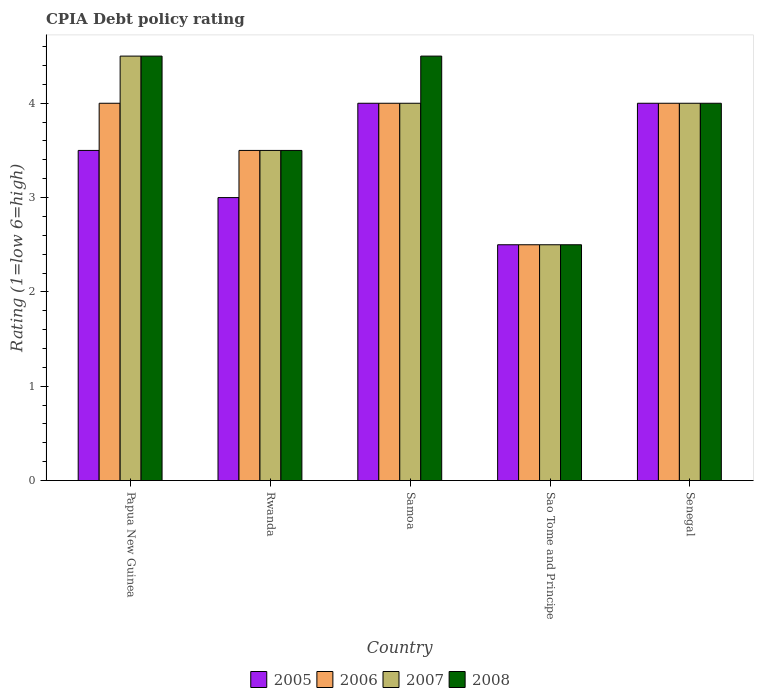How many different coloured bars are there?
Give a very brief answer. 4. How many groups of bars are there?
Provide a short and direct response. 5. Are the number of bars on each tick of the X-axis equal?
Provide a short and direct response. Yes. How many bars are there on the 4th tick from the right?
Give a very brief answer. 4. What is the label of the 3rd group of bars from the left?
Your response must be concise. Samoa. In how many cases, is the number of bars for a given country not equal to the number of legend labels?
Your answer should be very brief. 0. In which country was the CPIA rating in 2007 maximum?
Provide a succinct answer. Papua New Guinea. In which country was the CPIA rating in 2007 minimum?
Ensure brevity in your answer.  Sao Tome and Principe. What is the total CPIA rating in 2008 in the graph?
Give a very brief answer. 19. What is the difference between the CPIA rating in 2007 in Senegal and the CPIA rating in 2005 in Papua New Guinea?
Offer a terse response. 0.5. What is the difference between the highest and the lowest CPIA rating in 2008?
Give a very brief answer. 2. In how many countries, is the CPIA rating in 2005 greater than the average CPIA rating in 2005 taken over all countries?
Make the answer very short. 3. Is it the case that in every country, the sum of the CPIA rating in 2008 and CPIA rating in 2005 is greater than the sum of CPIA rating in 2007 and CPIA rating in 2006?
Make the answer very short. No. What does the 1st bar from the left in Samoa represents?
Offer a very short reply. 2005. What does the 2nd bar from the right in Senegal represents?
Your answer should be very brief. 2007. Is it the case that in every country, the sum of the CPIA rating in 2007 and CPIA rating in 2005 is greater than the CPIA rating in 2006?
Your answer should be compact. Yes. How many bars are there?
Ensure brevity in your answer.  20. Are all the bars in the graph horizontal?
Keep it short and to the point. No. Are the values on the major ticks of Y-axis written in scientific E-notation?
Your response must be concise. No. How many legend labels are there?
Make the answer very short. 4. What is the title of the graph?
Your answer should be compact. CPIA Debt policy rating. What is the Rating (1=low 6=high) in 2005 in Papua New Guinea?
Give a very brief answer. 3.5. What is the Rating (1=low 6=high) of 2007 in Papua New Guinea?
Your response must be concise. 4.5. What is the Rating (1=low 6=high) in 2005 in Rwanda?
Provide a succinct answer. 3. What is the Rating (1=low 6=high) in 2007 in Rwanda?
Provide a short and direct response. 3.5. What is the Rating (1=low 6=high) in 2008 in Rwanda?
Provide a succinct answer. 3.5. What is the Rating (1=low 6=high) of 2005 in Samoa?
Offer a very short reply. 4. What is the Rating (1=low 6=high) of 2007 in Samoa?
Offer a very short reply. 4. What is the Rating (1=low 6=high) in 2006 in Senegal?
Give a very brief answer. 4. What is the Rating (1=low 6=high) of 2007 in Senegal?
Make the answer very short. 4. What is the Rating (1=low 6=high) in 2008 in Senegal?
Provide a succinct answer. 4. Across all countries, what is the maximum Rating (1=low 6=high) of 2005?
Provide a short and direct response. 4. Across all countries, what is the maximum Rating (1=low 6=high) of 2006?
Provide a short and direct response. 4. Across all countries, what is the maximum Rating (1=low 6=high) in 2008?
Offer a very short reply. 4.5. Across all countries, what is the minimum Rating (1=low 6=high) of 2007?
Keep it short and to the point. 2.5. What is the difference between the Rating (1=low 6=high) in 2005 in Papua New Guinea and that in Rwanda?
Provide a succinct answer. 0.5. What is the difference between the Rating (1=low 6=high) of 2007 in Papua New Guinea and that in Rwanda?
Your response must be concise. 1. What is the difference between the Rating (1=low 6=high) in 2008 in Papua New Guinea and that in Samoa?
Your response must be concise. 0. What is the difference between the Rating (1=low 6=high) in 2005 in Papua New Guinea and that in Sao Tome and Principe?
Provide a succinct answer. 1. What is the difference between the Rating (1=low 6=high) of 2006 in Papua New Guinea and that in Sao Tome and Principe?
Ensure brevity in your answer.  1.5. What is the difference between the Rating (1=low 6=high) in 2005 in Papua New Guinea and that in Senegal?
Provide a short and direct response. -0.5. What is the difference between the Rating (1=low 6=high) in 2006 in Papua New Guinea and that in Senegal?
Offer a very short reply. 0. What is the difference between the Rating (1=low 6=high) in 2007 in Papua New Guinea and that in Senegal?
Make the answer very short. 0.5. What is the difference between the Rating (1=low 6=high) in 2007 in Rwanda and that in Samoa?
Provide a succinct answer. -0.5. What is the difference between the Rating (1=low 6=high) of 2007 in Rwanda and that in Sao Tome and Principe?
Ensure brevity in your answer.  1. What is the difference between the Rating (1=low 6=high) of 2005 in Rwanda and that in Senegal?
Keep it short and to the point. -1. What is the difference between the Rating (1=low 6=high) in 2007 in Rwanda and that in Senegal?
Keep it short and to the point. -0.5. What is the difference between the Rating (1=low 6=high) in 2005 in Samoa and that in Sao Tome and Principe?
Provide a succinct answer. 1.5. What is the difference between the Rating (1=low 6=high) in 2006 in Samoa and that in Sao Tome and Principe?
Ensure brevity in your answer.  1.5. What is the difference between the Rating (1=low 6=high) of 2007 in Samoa and that in Sao Tome and Principe?
Offer a very short reply. 1.5. What is the difference between the Rating (1=low 6=high) of 2008 in Samoa and that in Sao Tome and Principe?
Keep it short and to the point. 2. What is the difference between the Rating (1=low 6=high) of 2005 in Samoa and that in Senegal?
Make the answer very short. 0. What is the difference between the Rating (1=low 6=high) in 2007 in Samoa and that in Senegal?
Give a very brief answer. 0. What is the difference between the Rating (1=low 6=high) in 2005 in Sao Tome and Principe and that in Senegal?
Ensure brevity in your answer.  -1.5. What is the difference between the Rating (1=low 6=high) in 2007 in Sao Tome and Principe and that in Senegal?
Make the answer very short. -1.5. What is the difference between the Rating (1=low 6=high) in 2005 in Papua New Guinea and the Rating (1=low 6=high) in 2008 in Rwanda?
Provide a succinct answer. 0. What is the difference between the Rating (1=low 6=high) of 2007 in Papua New Guinea and the Rating (1=low 6=high) of 2008 in Rwanda?
Provide a succinct answer. 1. What is the difference between the Rating (1=low 6=high) of 2005 in Papua New Guinea and the Rating (1=low 6=high) of 2008 in Samoa?
Ensure brevity in your answer.  -1. What is the difference between the Rating (1=low 6=high) in 2006 in Papua New Guinea and the Rating (1=low 6=high) in 2008 in Samoa?
Keep it short and to the point. -0.5. What is the difference between the Rating (1=low 6=high) of 2005 in Papua New Guinea and the Rating (1=low 6=high) of 2008 in Sao Tome and Principe?
Your answer should be very brief. 1. What is the difference between the Rating (1=low 6=high) of 2007 in Papua New Guinea and the Rating (1=low 6=high) of 2008 in Sao Tome and Principe?
Make the answer very short. 2. What is the difference between the Rating (1=low 6=high) of 2006 in Papua New Guinea and the Rating (1=low 6=high) of 2007 in Senegal?
Give a very brief answer. 0. What is the difference between the Rating (1=low 6=high) of 2006 in Papua New Guinea and the Rating (1=low 6=high) of 2008 in Senegal?
Give a very brief answer. 0. What is the difference between the Rating (1=low 6=high) in 2007 in Papua New Guinea and the Rating (1=low 6=high) in 2008 in Senegal?
Your response must be concise. 0.5. What is the difference between the Rating (1=low 6=high) in 2005 in Rwanda and the Rating (1=low 6=high) in 2006 in Samoa?
Provide a succinct answer. -1. What is the difference between the Rating (1=low 6=high) in 2005 in Rwanda and the Rating (1=low 6=high) in 2008 in Samoa?
Ensure brevity in your answer.  -1.5. What is the difference between the Rating (1=low 6=high) of 2007 in Rwanda and the Rating (1=low 6=high) of 2008 in Samoa?
Your answer should be compact. -1. What is the difference between the Rating (1=low 6=high) in 2005 in Rwanda and the Rating (1=low 6=high) in 2006 in Sao Tome and Principe?
Provide a succinct answer. 0.5. What is the difference between the Rating (1=low 6=high) of 2005 in Rwanda and the Rating (1=low 6=high) of 2007 in Sao Tome and Principe?
Your response must be concise. 0.5. What is the difference between the Rating (1=low 6=high) in 2006 in Rwanda and the Rating (1=low 6=high) in 2008 in Sao Tome and Principe?
Make the answer very short. 1. What is the difference between the Rating (1=low 6=high) in 2005 in Rwanda and the Rating (1=low 6=high) in 2007 in Senegal?
Your answer should be very brief. -1. What is the difference between the Rating (1=low 6=high) in 2005 in Rwanda and the Rating (1=low 6=high) in 2008 in Senegal?
Your answer should be very brief. -1. What is the difference between the Rating (1=low 6=high) of 2006 in Rwanda and the Rating (1=low 6=high) of 2007 in Senegal?
Provide a succinct answer. -0.5. What is the difference between the Rating (1=low 6=high) of 2007 in Rwanda and the Rating (1=low 6=high) of 2008 in Senegal?
Your answer should be compact. -0.5. What is the difference between the Rating (1=low 6=high) in 2005 in Samoa and the Rating (1=low 6=high) in 2007 in Sao Tome and Principe?
Make the answer very short. 1.5. What is the difference between the Rating (1=low 6=high) of 2007 in Samoa and the Rating (1=low 6=high) of 2008 in Sao Tome and Principe?
Ensure brevity in your answer.  1.5. What is the difference between the Rating (1=low 6=high) of 2005 in Samoa and the Rating (1=low 6=high) of 2006 in Senegal?
Your response must be concise. 0. What is the difference between the Rating (1=low 6=high) in 2005 in Samoa and the Rating (1=low 6=high) in 2007 in Senegal?
Ensure brevity in your answer.  0. What is the difference between the Rating (1=low 6=high) in 2006 in Samoa and the Rating (1=low 6=high) in 2008 in Senegal?
Provide a short and direct response. 0. What is the difference between the Rating (1=low 6=high) in 2007 in Samoa and the Rating (1=low 6=high) in 2008 in Senegal?
Ensure brevity in your answer.  0. What is the difference between the Rating (1=low 6=high) of 2005 in Sao Tome and Principe and the Rating (1=low 6=high) of 2008 in Senegal?
Your answer should be compact. -1.5. What is the difference between the Rating (1=low 6=high) of 2006 in Sao Tome and Principe and the Rating (1=low 6=high) of 2008 in Senegal?
Your answer should be very brief. -1.5. What is the difference between the Rating (1=low 6=high) in 2007 in Sao Tome and Principe and the Rating (1=low 6=high) in 2008 in Senegal?
Make the answer very short. -1.5. What is the average Rating (1=low 6=high) in 2005 per country?
Offer a terse response. 3.4. What is the average Rating (1=low 6=high) of 2007 per country?
Your response must be concise. 3.7. What is the average Rating (1=low 6=high) in 2008 per country?
Give a very brief answer. 3.8. What is the difference between the Rating (1=low 6=high) in 2005 and Rating (1=low 6=high) in 2006 in Papua New Guinea?
Provide a short and direct response. -0.5. What is the difference between the Rating (1=low 6=high) in 2005 and Rating (1=low 6=high) in 2007 in Papua New Guinea?
Offer a terse response. -1. What is the difference between the Rating (1=low 6=high) in 2005 and Rating (1=low 6=high) in 2008 in Papua New Guinea?
Ensure brevity in your answer.  -1. What is the difference between the Rating (1=low 6=high) in 2006 and Rating (1=low 6=high) in 2007 in Papua New Guinea?
Provide a short and direct response. -0.5. What is the difference between the Rating (1=low 6=high) in 2006 and Rating (1=low 6=high) in 2008 in Papua New Guinea?
Offer a very short reply. -0.5. What is the difference between the Rating (1=low 6=high) of 2007 and Rating (1=low 6=high) of 2008 in Papua New Guinea?
Make the answer very short. 0. What is the difference between the Rating (1=low 6=high) of 2005 and Rating (1=low 6=high) of 2006 in Rwanda?
Make the answer very short. -0.5. What is the difference between the Rating (1=low 6=high) of 2005 and Rating (1=low 6=high) of 2007 in Rwanda?
Give a very brief answer. -0.5. What is the difference between the Rating (1=low 6=high) in 2005 and Rating (1=low 6=high) in 2008 in Rwanda?
Your answer should be compact. -0.5. What is the difference between the Rating (1=low 6=high) of 2006 and Rating (1=low 6=high) of 2007 in Rwanda?
Your answer should be very brief. 0. What is the difference between the Rating (1=low 6=high) in 2006 and Rating (1=low 6=high) in 2008 in Rwanda?
Provide a succinct answer. 0. What is the difference between the Rating (1=low 6=high) of 2007 and Rating (1=low 6=high) of 2008 in Rwanda?
Offer a terse response. 0. What is the difference between the Rating (1=low 6=high) of 2005 and Rating (1=low 6=high) of 2006 in Samoa?
Ensure brevity in your answer.  0. What is the difference between the Rating (1=low 6=high) in 2005 and Rating (1=low 6=high) in 2007 in Samoa?
Provide a succinct answer. 0. What is the difference between the Rating (1=low 6=high) in 2005 and Rating (1=low 6=high) in 2008 in Samoa?
Your answer should be compact. -0.5. What is the difference between the Rating (1=low 6=high) of 2006 and Rating (1=low 6=high) of 2007 in Samoa?
Ensure brevity in your answer.  0. What is the difference between the Rating (1=low 6=high) of 2005 and Rating (1=low 6=high) of 2008 in Sao Tome and Principe?
Provide a short and direct response. 0. What is the difference between the Rating (1=low 6=high) of 2006 and Rating (1=low 6=high) of 2007 in Sao Tome and Principe?
Offer a terse response. 0. What is the difference between the Rating (1=low 6=high) of 2006 and Rating (1=low 6=high) of 2008 in Sao Tome and Principe?
Ensure brevity in your answer.  0. What is the difference between the Rating (1=low 6=high) of 2006 and Rating (1=low 6=high) of 2008 in Senegal?
Provide a succinct answer. 0. What is the difference between the Rating (1=low 6=high) in 2007 and Rating (1=low 6=high) in 2008 in Senegal?
Your response must be concise. 0. What is the ratio of the Rating (1=low 6=high) of 2008 in Papua New Guinea to that in Rwanda?
Your response must be concise. 1.29. What is the ratio of the Rating (1=low 6=high) in 2005 in Papua New Guinea to that in Samoa?
Give a very brief answer. 0.88. What is the ratio of the Rating (1=low 6=high) in 2006 in Papua New Guinea to that in Samoa?
Your response must be concise. 1. What is the ratio of the Rating (1=low 6=high) in 2008 in Papua New Guinea to that in Samoa?
Ensure brevity in your answer.  1. What is the ratio of the Rating (1=low 6=high) of 2005 in Papua New Guinea to that in Sao Tome and Principe?
Provide a succinct answer. 1.4. What is the ratio of the Rating (1=low 6=high) in 2007 in Papua New Guinea to that in Sao Tome and Principe?
Offer a terse response. 1.8. What is the ratio of the Rating (1=low 6=high) in 2008 in Papua New Guinea to that in Sao Tome and Principe?
Offer a very short reply. 1.8. What is the ratio of the Rating (1=low 6=high) in 2006 in Papua New Guinea to that in Senegal?
Provide a short and direct response. 1. What is the ratio of the Rating (1=low 6=high) in 2007 in Papua New Guinea to that in Senegal?
Provide a short and direct response. 1.12. What is the ratio of the Rating (1=low 6=high) of 2008 in Papua New Guinea to that in Senegal?
Offer a very short reply. 1.12. What is the ratio of the Rating (1=low 6=high) of 2005 in Rwanda to that in Samoa?
Provide a short and direct response. 0.75. What is the ratio of the Rating (1=low 6=high) of 2008 in Rwanda to that in Samoa?
Give a very brief answer. 0.78. What is the ratio of the Rating (1=low 6=high) in 2005 in Rwanda to that in Sao Tome and Principe?
Your response must be concise. 1.2. What is the ratio of the Rating (1=low 6=high) of 2007 in Rwanda to that in Sao Tome and Principe?
Provide a succinct answer. 1.4. What is the ratio of the Rating (1=low 6=high) of 2008 in Rwanda to that in Senegal?
Your answer should be compact. 0.88. What is the ratio of the Rating (1=low 6=high) of 2006 in Samoa to that in Sao Tome and Principe?
Your response must be concise. 1.6. What is the ratio of the Rating (1=low 6=high) in 2007 in Samoa to that in Sao Tome and Principe?
Give a very brief answer. 1.6. What is the ratio of the Rating (1=low 6=high) of 2005 in Samoa to that in Senegal?
Your response must be concise. 1. What is the ratio of the Rating (1=low 6=high) in 2006 in Samoa to that in Senegal?
Your answer should be very brief. 1. What is the ratio of the Rating (1=low 6=high) of 2007 in Samoa to that in Senegal?
Your answer should be very brief. 1. What is the ratio of the Rating (1=low 6=high) of 2008 in Samoa to that in Senegal?
Keep it short and to the point. 1.12. What is the ratio of the Rating (1=low 6=high) in 2005 in Sao Tome and Principe to that in Senegal?
Give a very brief answer. 0.62. What is the ratio of the Rating (1=low 6=high) in 2007 in Sao Tome and Principe to that in Senegal?
Ensure brevity in your answer.  0.62. What is the ratio of the Rating (1=low 6=high) in 2008 in Sao Tome and Principe to that in Senegal?
Give a very brief answer. 0.62. What is the difference between the highest and the second highest Rating (1=low 6=high) of 2005?
Your answer should be very brief. 0. What is the difference between the highest and the second highest Rating (1=low 6=high) of 2007?
Ensure brevity in your answer.  0.5. What is the difference between the highest and the second highest Rating (1=low 6=high) in 2008?
Give a very brief answer. 0. What is the difference between the highest and the lowest Rating (1=low 6=high) in 2005?
Provide a succinct answer. 1.5. What is the difference between the highest and the lowest Rating (1=low 6=high) of 2007?
Your answer should be very brief. 2. 